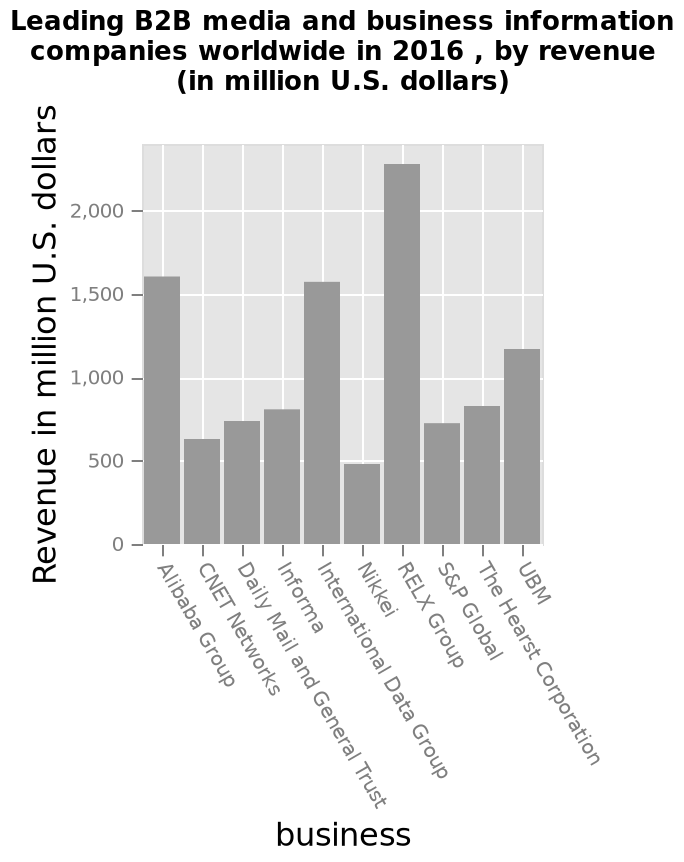<image>
Which company has the lowest revenue? Nikkei has the lowest revenue. What is the revenue of UBM in million U.S. dollars? The revenue of UBM in million U.S. dollars is not provided in the description. 